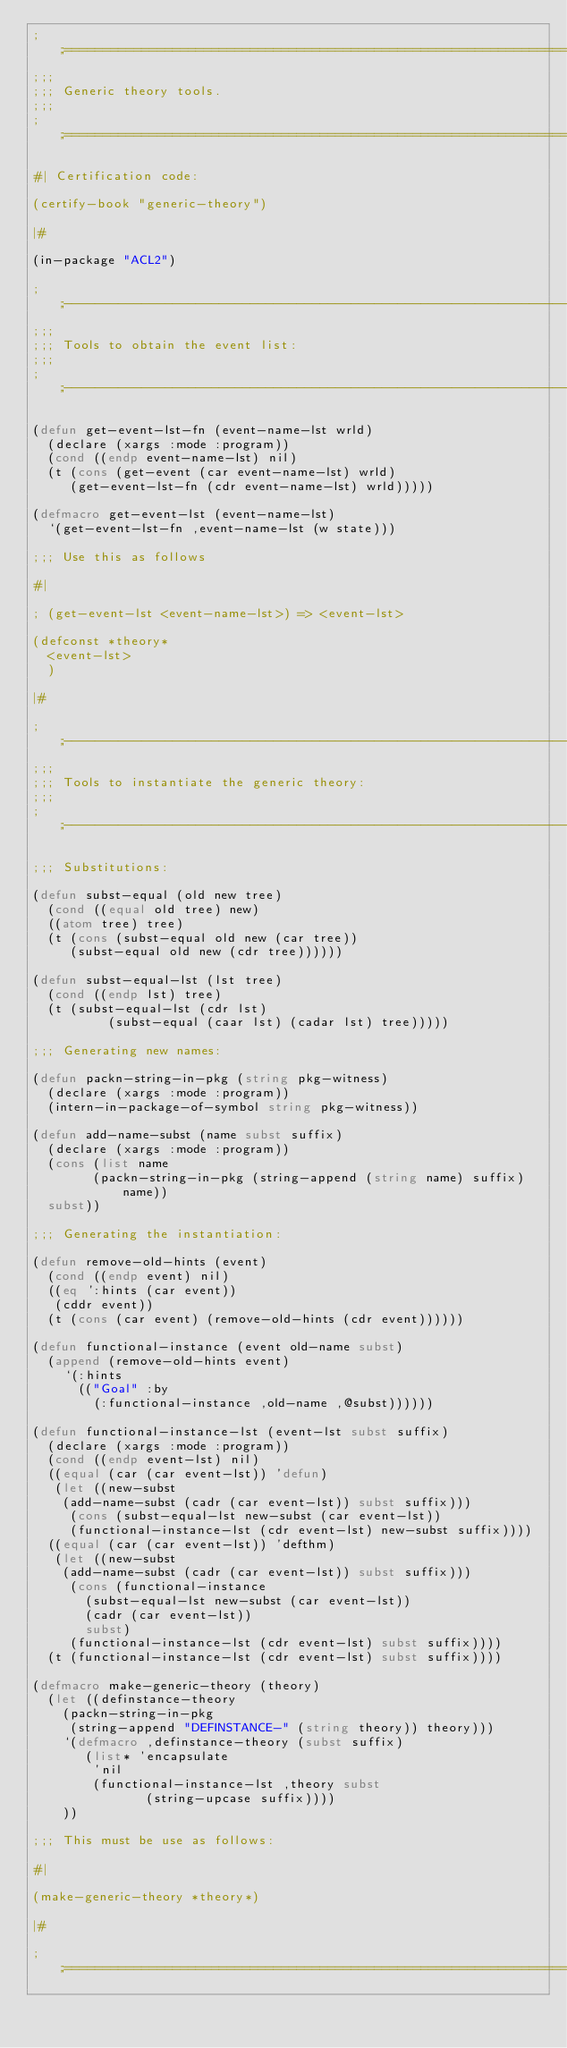<code> <loc_0><loc_0><loc_500><loc_500><_Lisp_>;;;============================================================================
;;;
;;; Generic theory tools.
;;;
;;;============================================================================

#| Certification code:

(certify-book "generic-theory")

|#

(in-package "ACL2")

;;;----------------------------------------------------------------------------
;;;
;;; Tools to obtain the event list:
;;;
;;;----------------------------------------------------------------------------

(defun get-event-lst-fn (event-name-lst wrld)
  (declare (xargs :mode :program))
  (cond ((endp event-name-lst) nil)
	(t (cons (get-event (car event-name-lst) wrld)
		 (get-event-lst-fn (cdr event-name-lst) wrld)))))

(defmacro get-event-lst (event-name-lst)
  `(get-event-lst-fn ,event-name-lst (w state)))

;;; Use this as follows

#|

; (get-event-lst <event-name-lst>) => <event-lst>

(defconst *theory*
  <event-lst>
  )

|#

;;;----------------------------------------------------------------------------
;;;
;;; Tools to instantiate the generic theory:
;;;
;;;----------------------------------------------------------------------------

;;; Substitutions:

(defun subst-equal (old new tree)
  (cond ((equal old tree) new)
	((atom tree) tree)
	(t (cons (subst-equal old new (car tree))
		 (subst-equal old new (cdr tree))))))

(defun subst-equal-lst (lst tree)
  (cond ((endp lst) tree)
	(t (subst-equal-lst (cdr lst)
			    (subst-equal (caar lst) (cadar lst) tree)))))

;;; Generating new names:

(defun packn-string-in-pkg (string pkg-witness)
  (declare (xargs :mode :program))
  (intern-in-package-of-symbol string pkg-witness))

(defun add-name-subst (name subst suffix)
  (declare (xargs :mode :program))
  (cons (list name 
	      (packn-string-in-pkg (string-append (string name) suffix) name))
	subst))

;;; Generating the instantiation:

(defun remove-old-hints (event)
  (cond ((endp event) nil)
	((eq ':hints (car event))
	 (cddr event))
	(t (cons (car event) (remove-old-hints (cdr event))))))

(defun functional-instance (event old-name subst)
  (append (remove-old-hints event)
	  `(:hints
	    (("Goal" :by
	      (:functional-instance ,old-name ,@subst))))))

(defun functional-instance-lst (event-lst subst suffix)
  (declare (xargs :mode :program))
  (cond ((endp event-lst) nil)
	((equal (car (car event-lst)) 'defun)
	 (let ((new-subst
		(add-name-subst (cadr (car event-lst)) subst suffix)))
	   (cons (subst-equal-lst new-subst (car event-lst))
		 (functional-instance-lst (cdr event-lst) new-subst suffix))))
	((equal (car (car event-lst)) 'defthm)
	 (let ((new-subst
		(add-name-subst (cadr (car event-lst)) subst suffix)))
	   (cons (functional-instance
		   (subst-equal-lst new-subst (car event-lst))
		   (cadr (car event-lst))
		   subst)
		 (functional-instance-lst (cdr event-lst) subst suffix))))
	(t (functional-instance-lst (cdr event-lst) subst suffix))))

(defmacro make-generic-theory (theory)
  (let ((definstance-theory
	  (packn-string-in-pkg 
	   (string-append "DEFINSTANCE-" (string theory)) theory)))    
    `(defmacro ,definstance-theory (subst suffix)
       (list* 'encapsulate
	      'nil
	      (functional-instance-lst ,theory subst
				       (string-upcase suffix))))
    ))

;;; This must be use as follows:

#|

(make-generic-theory *theory*)

|#

;;;============================================================================
</code> 